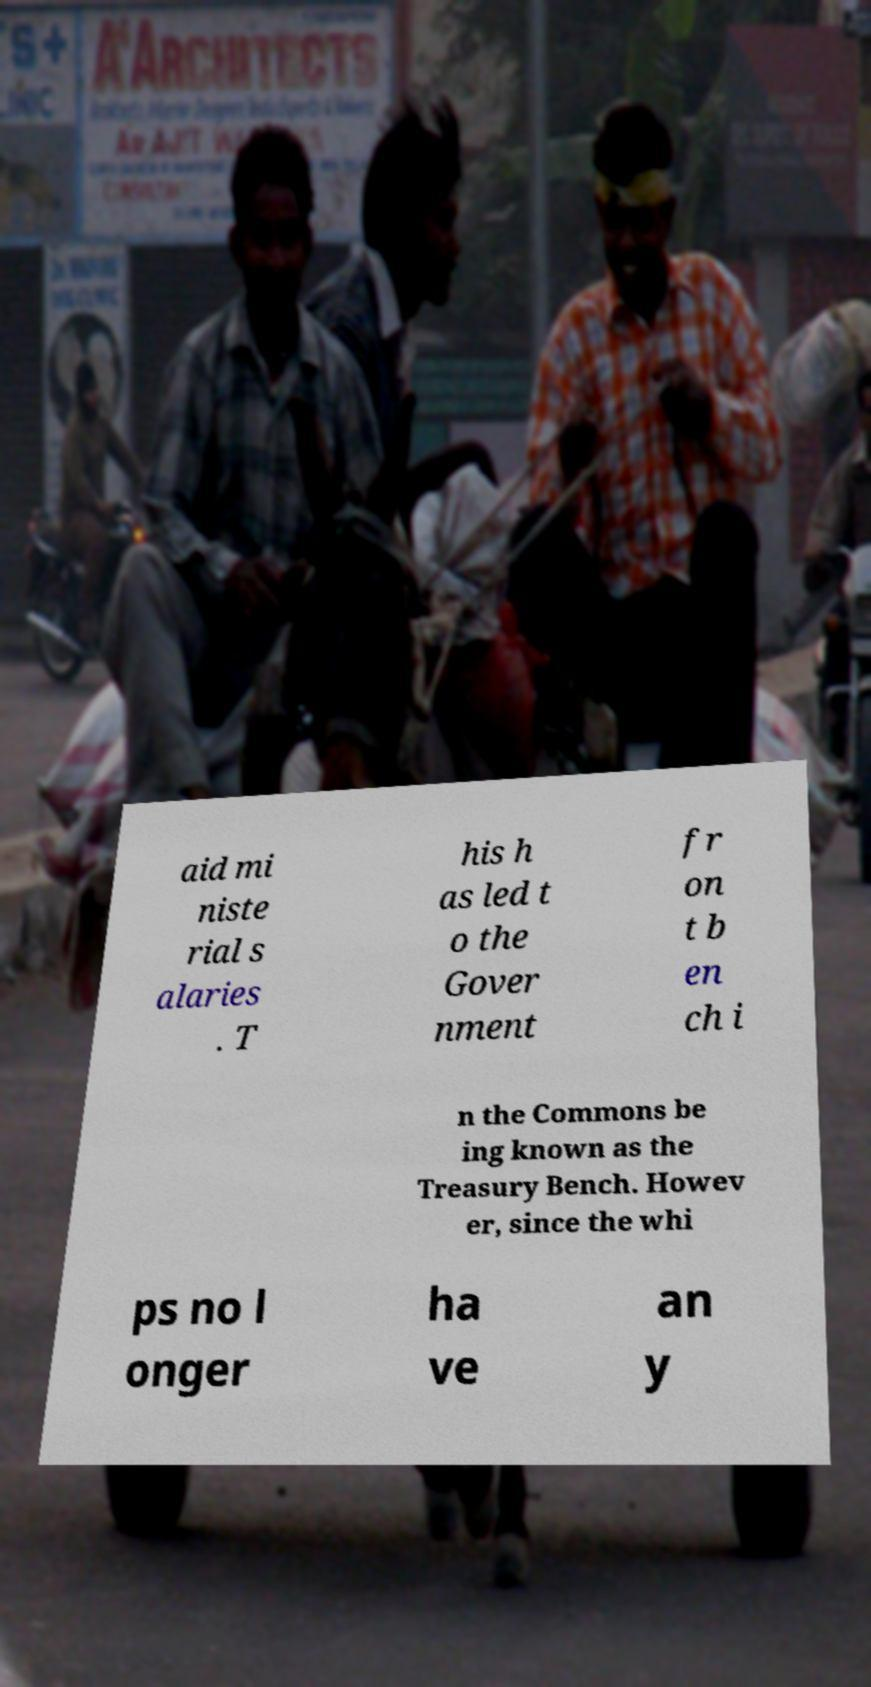For documentation purposes, I need the text within this image transcribed. Could you provide that? aid mi niste rial s alaries . T his h as led t o the Gover nment fr on t b en ch i n the Commons be ing known as the Treasury Bench. Howev er, since the whi ps no l onger ha ve an y 